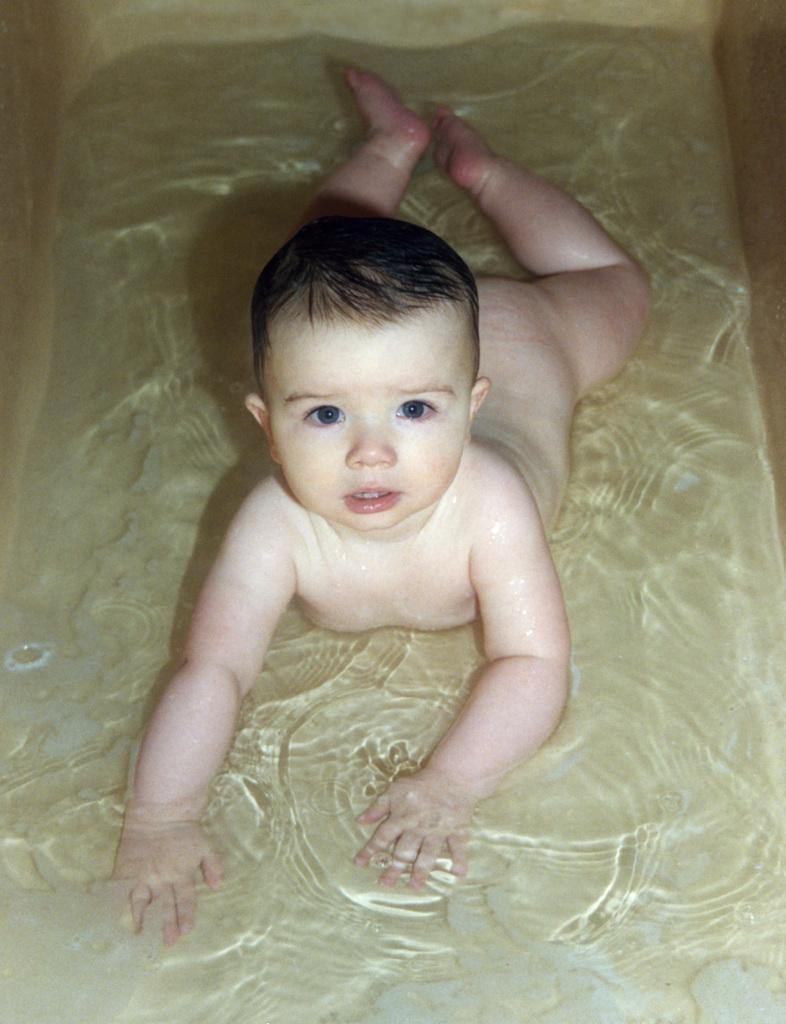Could you give a brief overview of what you see in this image? In this image we can see a baby lying in the water. 